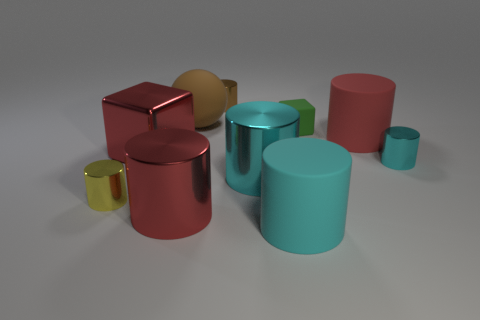There is a yellow thing that is made of the same material as the big red block; what is its shape?
Your answer should be compact. Cylinder. Is there anything else that has the same color as the big metallic block?
Keep it short and to the point. Yes. Are there more yellow shiny things to the right of the small green matte block than large metal things?
Your answer should be compact. No. What is the material of the small green block?
Ensure brevity in your answer.  Rubber. How many brown matte objects are the same size as the brown metal object?
Give a very brief answer. 0. Are there an equal number of large red blocks that are behind the large brown matte object and big shiny cubes that are in front of the yellow object?
Offer a terse response. Yes. Does the small cyan cylinder have the same material as the tiny brown cylinder?
Make the answer very short. Yes. There is a red cylinder that is to the left of the tiny brown shiny thing; is there a green rubber cube to the left of it?
Offer a terse response. No. Are there any small cyan objects that have the same shape as the big brown matte object?
Your answer should be compact. No. Does the rubber cube have the same color as the large rubber ball?
Your response must be concise. No. 